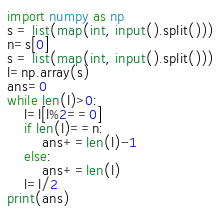Convert code to text. <code><loc_0><loc_0><loc_500><loc_500><_Python_>import numpy as np
s = list(map(int, input().split()))
n=s[0]
s = list(map(int, input().split()))
l=np.array(s)
ans=0
while len(l)>0:
    l=l[l%2==0]
    if len(l)==n:  
        ans+=len(l)-1
    else:
        ans+=len(l)
    l=l/2
print(ans)
</code> 